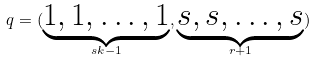<formula> <loc_0><loc_0><loc_500><loc_500>q = ( \underbrace { 1 , 1 , \dots , 1 } _ { s k - 1 } , \underbrace { s , s , \dots , s } _ { r + 1 } ) \,</formula> 